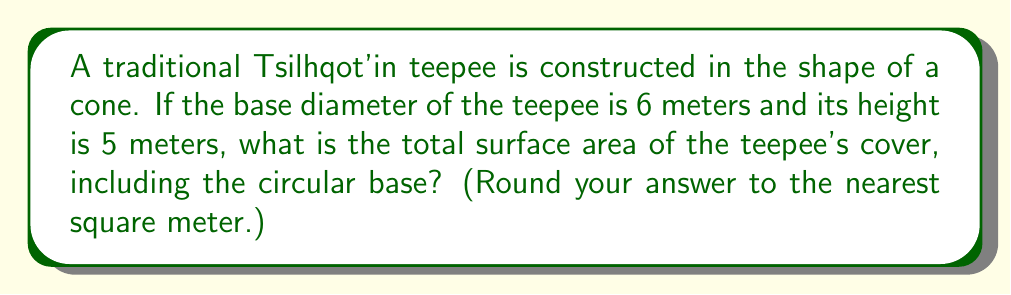Show me your answer to this math problem. Let's approach this step-by-step:

1) First, we need to find the radius of the base:
   Diameter = 6 m, so radius $r = 3$ m

2) We know the height $h = 5$ m

3) To find the surface area, we need to calculate:
   a) The area of the circular base
   b) The lateral surface area of the cone

4) Area of the circular base:
   $A_{base} = \pi r^2 = \pi (3)^2 = 9\pi$ m²

5) For the lateral surface area, we need to find the slant height $l$:
   $l^2 = r^2 + h^2$ (Pythagorean theorem)
   $l^2 = 3^2 + 5^2 = 9 + 25 = 34$
   $l = \sqrt{34}$ m

6) Lateral surface area:
   $A_{lateral} = \pi r l = \pi (3)(\sqrt{34})$ m²

7) Total surface area:
   $A_{total} = A_{base} + A_{lateral} = 9\pi + 3\pi\sqrt{34}$ m²

8) Simplifying:
   $A_{total} = \pi(9 + 3\sqrt{34})$ m²

9) Calculating:
   $A_{total} \approx 3.14159(9 + 3(5.83095)) \approx 82.0$ m²

10) Rounding to the nearest square meter:
    $A_{total} \approx 82$ m²
Answer: 82 m² 